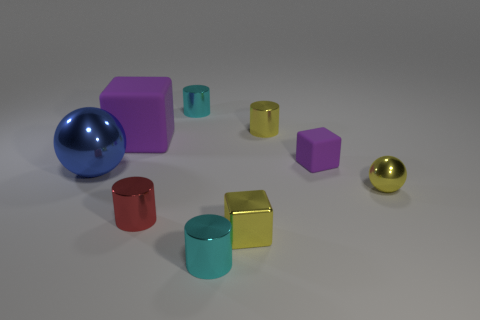Subtract 1 cylinders. How many cylinders are left? 3 Subtract all brown cylinders. Subtract all blue blocks. How many cylinders are left? 4 Add 1 small yellow shiny blocks. How many objects exist? 10 Subtract all blocks. How many objects are left? 6 Add 4 large shiny cubes. How many large shiny cubes exist? 4 Subtract 0 cyan blocks. How many objects are left? 9 Subtract all cyan cylinders. Subtract all red things. How many objects are left? 6 Add 6 tiny purple blocks. How many tiny purple blocks are left? 7 